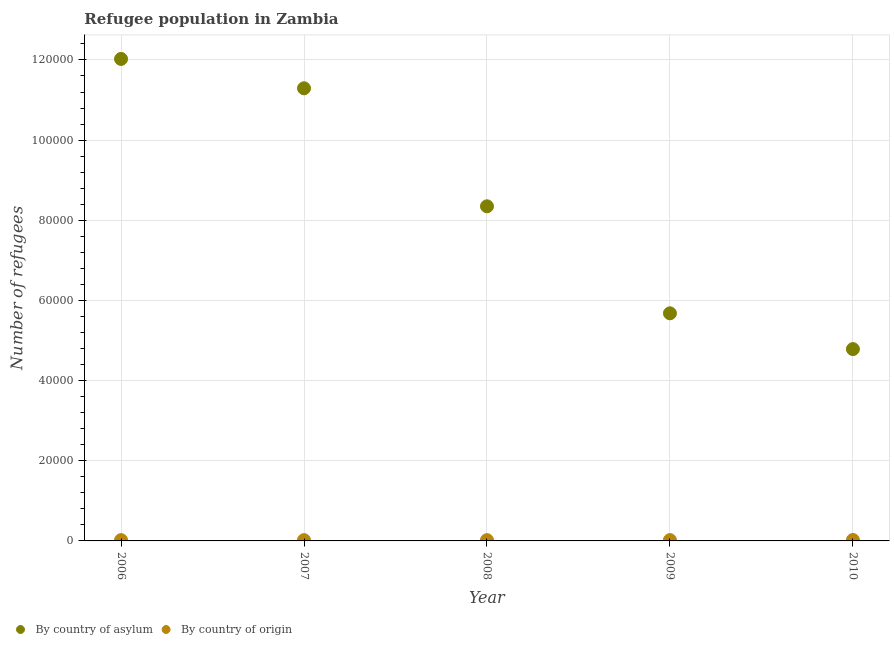What is the number of refugees by country of origin in 2007?
Your answer should be compact. 196. Across all years, what is the maximum number of refugees by country of asylum?
Provide a succinct answer. 1.20e+05. Across all years, what is the minimum number of refugees by country of asylum?
Your answer should be very brief. 4.79e+04. In which year was the number of refugees by country of asylum minimum?
Ensure brevity in your answer.  2010. What is the total number of refugees by country of origin in the graph?
Provide a short and direct response. 1028. What is the difference between the number of refugees by country of asylum in 2006 and that in 2009?
Offer a very short reply. 6.35e+04. What is the difference between the number of refugees by country of origin in 2010 and the number of refugees by country of asylum in 2006?
Give a very brief answer. -1.20e+05. What is the average number of refugees by country of asylum per year?
Offer a very short reply. 8.43e+04. In the year 2009, what is the difference between the number of refugees by country of asylum and number of refugees by country of origin?
Offer a terse response. 5.66e+04. What is the ratio of the number of refugees by country of origin in 2009 to that in 2010?
Offer a terse response. 0.9. What is the difference between the highest and the lowest number of refugees by country of origin?
Your response must be concise. 33. Is the sum of the number of refugees by country of origin in 2008 and 2009 greater than the maximum number of refugees by country of asylum across all years?
Your response must be concise. No. Does the number of refugees by country of asylum monotonically increase over the years?
Your answer should be compact. No. Is the number of refugees by country of asylum strictly less than the number of refugees by country of origin over the years?
Provide a short and direct response. No. How many years are there in the graph?
Your response must be concise. 5. Does the graph contain grids?
Your answer should be very brief. Yes. Where does the legend appear in the graph?
Your answer should be compact. Bottom left. How many legend labels are there?
Offer a terse response. 2. How are the legend labels stacked?
Your answer should be very brief. Horizontal. What is the title of the graph?
Your answer should be very brief. Refugee population in Zambia. What is the label or title of the X-axis?
Give a very brief answer. Year. What is the label or title of the Y-axis?
Give a very brief answer. Number of refugees. What is the Number of refugees of By country of asylum in 2006?
Your response must be concise. 1.20e+05. What is the Number of refugees in By country of origin in 2006?
Keep it short and to the point. 203. What is the Number of refugees of By country of asylum in 2007?
Give a very brief answer. 1.13e+05. What is the Number of refugees of By country of origin in 2007?
Provide a succinct answer. 196. What is the Number of refugees in By country of asylum in 2008?
Make the answer very short. 8.35e+04. What is the Number of refugees of By country of origin in 2008?
Offer a terse response. 195. What is the Number of refugees of By country of asylum in 2009?
Your answer should be compact. 5.68e+04. What is the Number of refugees of By country of origin in 2009?
Your answer should be compact. 206. What is the Number of refugees in By country of asylum in 2010?
Your answer should be very brief. 4.79e+04. What is the Number of refugees of By country of origin in 2010?
Make the answer very short. 228. Across all years, what is the maximum Number of refugees in By country of asylum?
Offer a very short reply. 1.20e+05. Across all years, what is the maximum Number of refugees of By country of origin?
Make the answer very short. 228. Across all years, what is the minimum Number of refugees of By country of asylum?
Provide a short and direct response. 4.79e+04. Across all years, what is the minimum Number of refugees in By country of origin?
Ensure brevity in your answer.  195. What is the total Number of refugees in By country of asylum in the graph?
Offer a terse response. 4.21e+05. What is the total Number of refugees in By country of origin in the graph?
Ensure brevity in your answer.  1028. What is the difference between the Number of refugees in By country of asylum in 2006 and that in 2007?
Provide a short and direct response. 7322. What is the difference between the Number of refugees in By country of origin in 2006 and that in 2007?
Ensure brevity in your answer.  7. What is the difference between the Number of refugees of By country of asylum in 2006 and that in 2008?
Give a very brief answer. 3.68e+04. What is the difference between the Number of refugees of By country of origin in 2006 and that in 2008?
Give a very brief answer. 8. What is the difference between the Number of refugees in By country of asylum in 2006 and that in 2009?
Provide a succinct answer. 6.35e+04. What is the difference between the Number of refugees of By country of origin in 2006 and that in 2009?
Keep it short and to the point. -3. What is the difference between the Number of refugees in By country of asylum in 2006 and that in 2010?
Provide a succinct answer. 7.24e+04. What is the difference between the Number of refugees in By country of asylum in 2007 and that in 2008?
Your response must be concise. 2.94e+04. What is the difference between the Number of refugees of By country of asylum in 2007 and that in 2009?
Offer a terse response. 5.61e+04. What is the difference between the Number of refugees in By country of origin in 2007 and that in 2009?
Provide a short and direct response. -10. What is the difference between the Number of refugees in By country of asylum in 2007 and that in 2010?
Offer a terse response. 6.51e+04. What is the difference between the Number of refugees in By country of origin in 2007 and that in 2010?
Your response must be concise. -32. What is the difference between the Number of refugees in By country of asylum in 2008 and that in 2009?
Keep it short and to the point. 2.67e+04. What is the difference between the Number of refugees in By country of origin in 2008 and that in 2009?
Ensure brevity in your answer.  -11. What is the difference between the Number of refugees of By country of asylum in 2008 and that in 2010?
Your response must be concise. 3.56e+04. What is the difference between the Number of refugees in By country of origin in 2008 and that in 2010?
Make the answer very short. -33. What is the difference between the Number of refugees in By country of asylum in 2009 and that in 2010?
Give a very brief answer. 8928. What is the difference between the Number of refugees of By country of origin in 2009 and that in 2010?
Ensure brevity in your answer.  -22. What is the difference between the Number of refugees of By country of asylum in 2006 and the Number of refugees of By country of origin in 2007?
Your response must be concise. 1.20e+05. What is the difference between the Number of refugees of By country of asylum in 2006 and the Number of refugees of By country of origin in 2008?
Offer a terse response. 1.20e+05. What is the difference between the Number of refugees in By country of asylum in 2006 and the Number of refugees in By country of origin in 2009?
Your response must be concise. 1.20e+05. What is the difference between the Number of refugees in By country of asylum in 2006 and the Number of refugees in By country of origin in 2010?
Your response must be concise. 1.20e+05. What is the difference between the Number of refugees in By country of asylum in 2007 and the Number of refugees in By country of origin in 2008?
Offer a terse response. 1.13e+05. What is the difference between the Number of refugees of By country of asylum in 2007 and the Number of refugees of By country of origin in 2009?
Offer a very short reply. 1.13e+05. What is the difference between the Number of refugees of By country of asylum in 2007 and the Number of refugees of By country of origin in 2010?
Make the answer very short. 1.13e+05. What is the difference between the Number of refugees of By country of asylum in 2008 and the Number of refugees of By country of origin in 2009?
Ensure brevity in your answer.  8.33e+04. What is the difference between the Number of refugees of By country of asylum in 2008 and the Number of refugees of By country of origin in 2010?
Provide a succinct answer. 8.33e+04. What is the difference between the Number of refugees in By country of asylum in 2009 and the Number of refugees in By country of origin in 2010?
Ensure brevity in your answer.  5.66e+04. What is the average Number of refugees of By country of asylum per year?
Ensure brevity in your answer.  8.43e+04. What is the average Number of refugees of By country of origin per year?
Give a very brief answer. 205.6. In the year 2006, what is the difference between the Number of refugees in By country of asylum and Number of refugees in By country of origin?
Your response must be concise. 1.20e+05. In the year 2007, what is the difference between the Number of refugees in By country of asylum and Number of refugees in By country of origin?
Make the answer very short. 1.13e+05. In the year 2008, what is the difference between the Number of refugees in By country of asylum and Number of refugees in By country of origin?
Offer a terse response. 8.33e+04. In the year 2009, what is the difference between the Number of refugees of By country of asylum and Number of refugees of By country of origin?
Offer a very short reply. 5.66e+04. In the year 2010, what is the difference between the Number of refugees in By country of asylum and Number of refugees in By country of origin?
Give a very brief answer. 4.76e+04. What is the ratio of the Number of refugees of By country of asylum in 2006 to that in 2007?
Your answer should be very brief. 1.06. What is the ratio of the Number of refugees of By country of origin in 2006 to that in 2007?
Offer a very short reply. 1.04. What is the ratio of the Number of refugees of By country of asylum in 2006 to that in 2008?
Make the answer very short. 1.44. What is the ratio of the Number of refugees of By country of origin in 2006 to that in 2008?
Give a very brief answer. 1.04. What is the ratio of the Number of refugees in By country of asylum in 2006 to that in 2009?
Your answer should be very brief. 2.12. What is the ratio of the Number of refugees in By country of origin in 2006 to that in 2009?
Provide a succinct answer. 0.99. What is the ratio of the Number of refugees of By country of asylum in 2006 to that in 2010?
Your response must be concise. 2.51. What is the ratio of the Number of refugees in By country of origin in 2006 to that in 2010?
Give a very brief answer. 0.89. What is the ratio of the Number of refugees in By country of asylum in 2007 to that in 2008?
Offer a very short reply. 1.35. What is the ratio of the Number of refugees in By country of origin in 2007 to that in 2008?
Your response must be concise. 1.01. What is the ratio of the Number of refugees in By country of asylum in 2007 to that in 2009?
Make the answer very short. 1.99. What is the ratio of the Number of refugees of By country of origin in 2007 to that in 2009?
Ensure brevity in your answer.  0.95. What is the ratio of the Number of refugees of By country of asylum in 2007 to that in 2010?
Keep it short and to the point. 2.36. What is the ratio of the Number of refugees of By country of origin in 2007 to that in 2010?
Offer a very short reply. 0.86. What is the ratio of the Number of refugees in By country of asylum in 2008 to that in 2009?
Your answer should be compact. 1.47. What is the ratio of the Number of refugees in By country of origin in 2008 to that in 2009?
Give a very brief answer. 0.95. What is the ratio of the Number of refugees of By country of asylum in 2008 to that in 2010?
Offer a terse response. 1.74. What is the ratio of the Number of refugees in By country of origin in 2008 to that in 2010?
Your answer should be compact. 0.86. What is the ratio of the Number of refugees in By country of asylum in 2009 to that in 2010?
Your answer should be very brief. 1.19. What is the ratio of the Number of refugees of By country of origin in 2009 to that in 2010?
Give a very brief answer. 0.9. What is the difference between the highest and the second highest Number of refugees of By country of asylum?
Provide a succinct answer. 7322. What is the difference between the highest and the second highest Number of refugees in By country of origin?
Offer a very short reply. 22. What is the difference between the highest and the lowest Number of refugees in By country of asylum?
Give a very brief answer. 7.24e+04. 